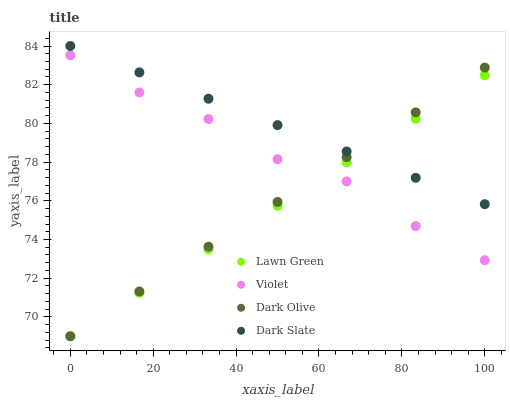Does Lawn Green have the minimum area under the curve?
Answer yes or no. Yes. Does Dark Slate have the maximum area under the curve?
Answer yes or no. Yes. Does Dark Olive have the minimum area under the curve?
Answer yes or no. No. Does Dark Olive have the maximum area under the curve?
Answer yes or no. No. Is Lawn Green the smoothest?
Answer yes or no. Yes. Is Violet the roughest?
Answer yes or no. Yes. Is Dark Olive the smoothest?
Answer yes or no. No. Is Dark Olive the roughest?
Answer yes or no. No. Does Lawn Green have the lowest value?
Answer yes or no. Yes. Does Dark Slate have the lowest value?
Answer yes or no. No. Does Dark Slate have the highest value?
Answer yes or no. Yes. Does Dark Olive have the highest value?
Answer yes or no. No. Is Violet less than Dark Slate?
Answer yes or no. Yes. Is Dark Slate greater than Violet?
Answer yes or no. Yes. Does Violet intersect Dark Olive?
Answer yes or no. Yes. Is Violet less than Dark Olive?
Answer yes or no. No. Is Violet greater than Dark Olive?
Answer yes or no. No. Does Violet intersect Dark Slate?
Answer yes or no. No. 